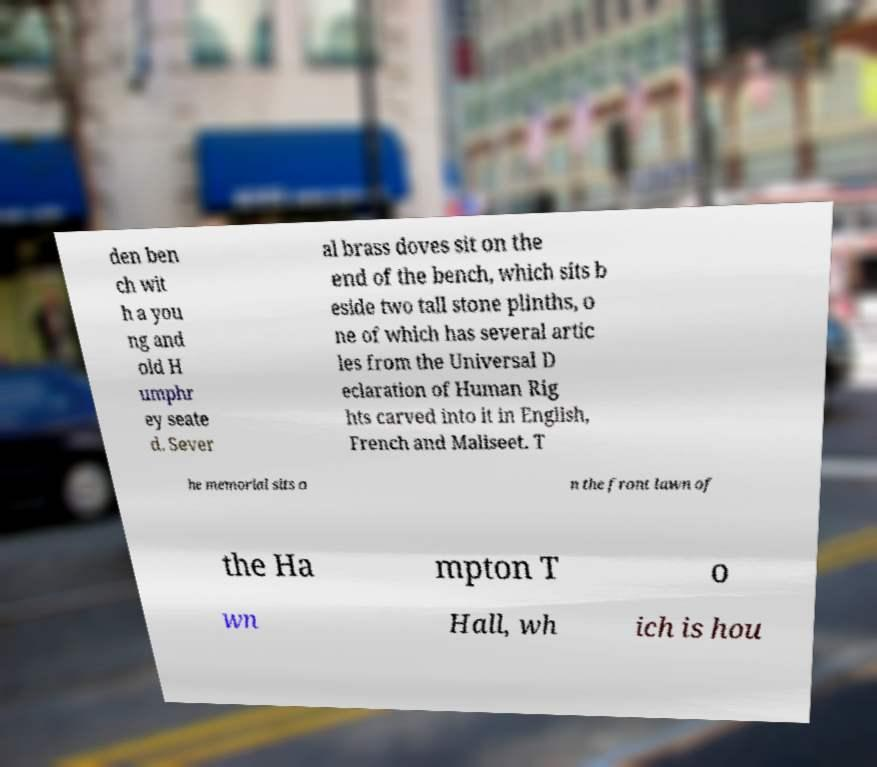For documentation purposes, I need the text within this image transcribed. Could you provide that? den ben ch wit h a you ng and old H umphr ey seate d. Sever al brass doves sit on the end of the bench, which sits b eside two tall stone plinths, o ne of which has several artic les from the Universal D eclaration of Human Rig hts carved into it in English, French and Maliseet. T he memorial sits o n the front lawn of the Ha mpton T o wn Hall, wh ich is hou 